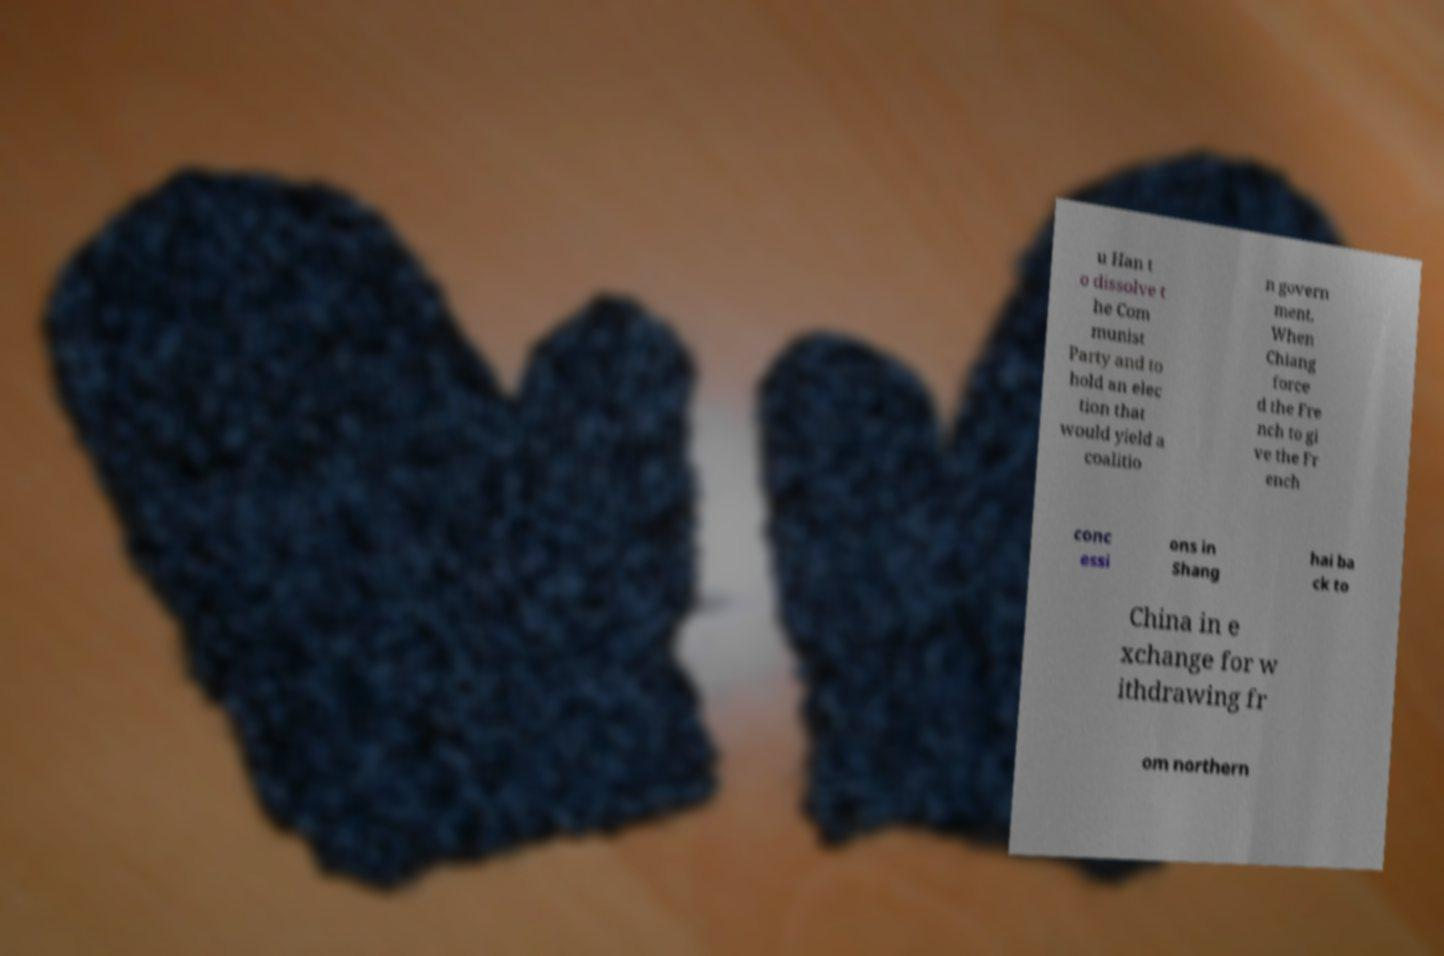Can you accurately transcribe the text from the provided image for me? u Han t o dissolve t he Com munist Party and to hold an elec tion that would yield a coalitio n govern ment. When Chiang force d the Fre nch to gi ve the Fr ench conc essi ons in Shang hai ba ck to China in e xchange for w ithdrawing fr om northern 